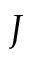<formula> <loc_0><loc_0><loc_500><loc_500>J</formula> 